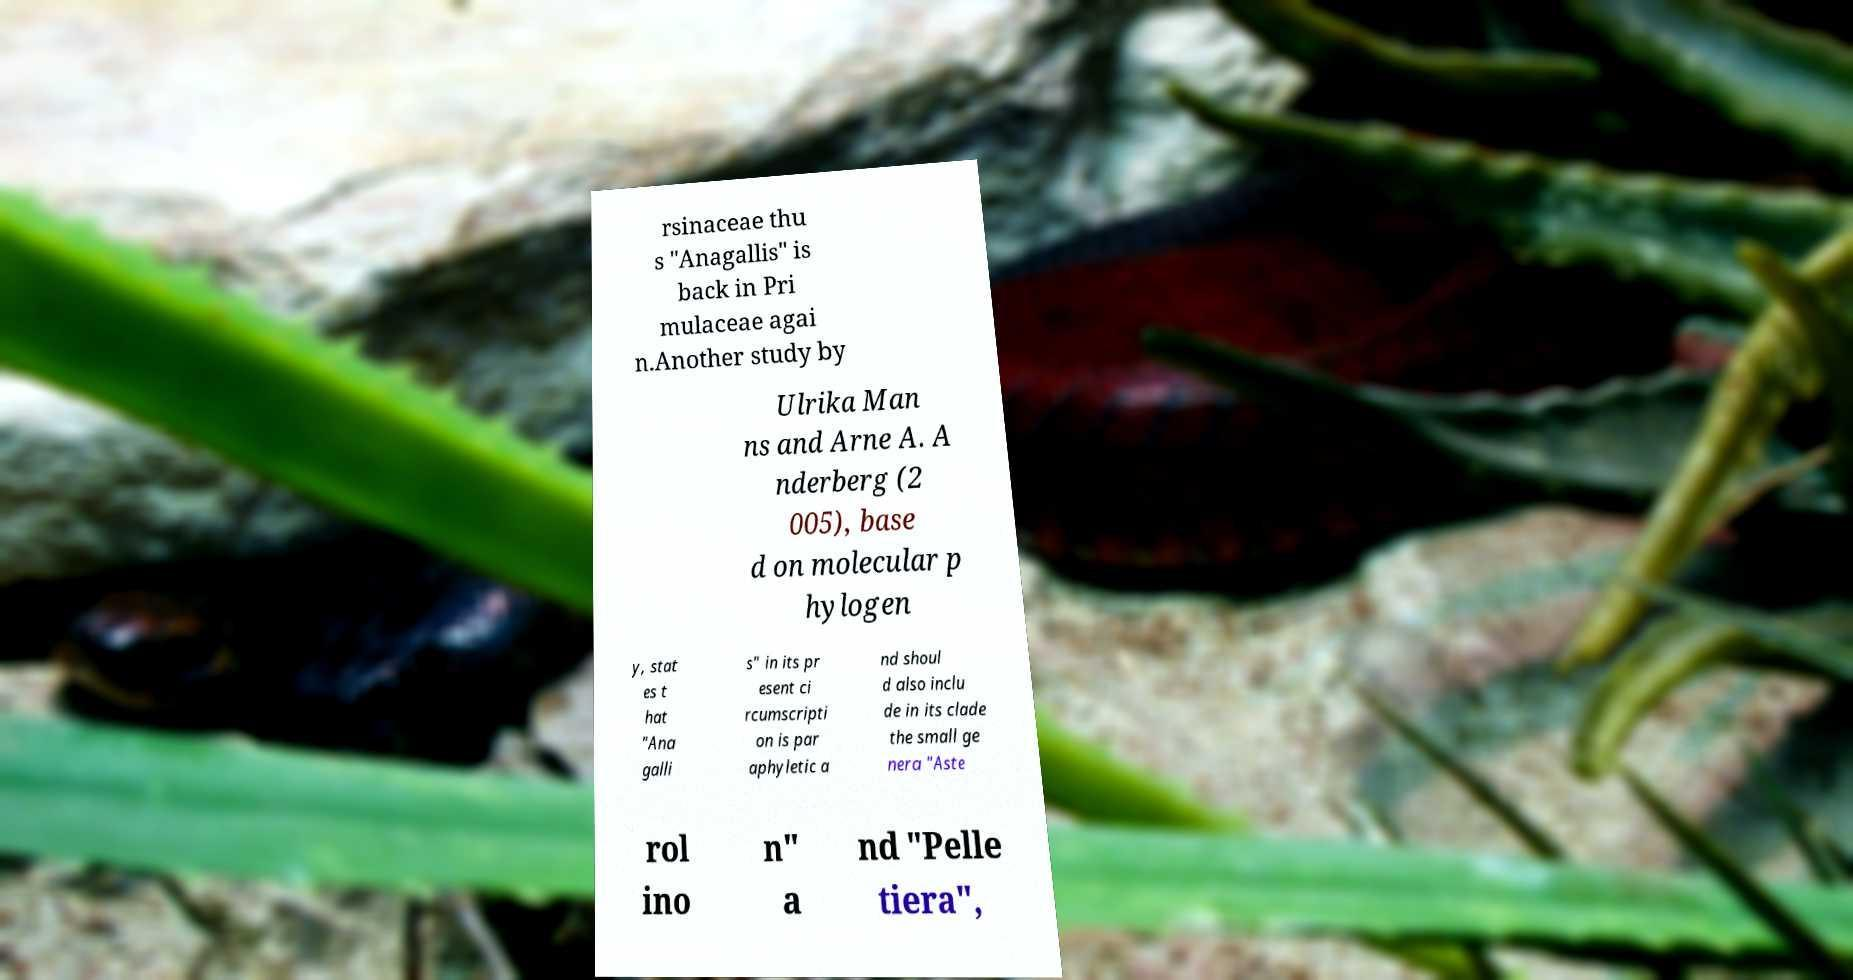What messages or text are displayed in this image? I need them in a readable, typed format. rsinaceae thu s "Anagallis" is back in Pri mulaceae agai n.Another study by Ulrika Man ns and Arne A. A nderberg (2 005), base d on molecular p hylogen y, stat es t hat "Ana galli s" in its pr esent ci rcumscripti on is par aphyletic a nd shoul d also inclu de in its clade the small ge nera "Aste rol ino n" a nd "Pelle tiera", 